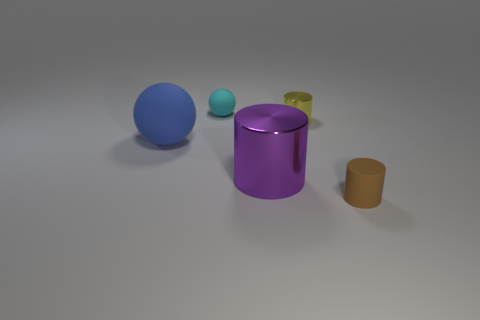Add 3 large metallic things. How many objects exist? 8 Subtract all cylinders. How many objects are left? 2 Add 2 tiny blue metallic cylinders. How many tiny blue metallic cylinders exist? 2 Subtract 0 green cylinders. How many objects are left? 5 Subtract all small yellow shiny cylinders. Subtract all big yellow metallic cylinders. How many objects are left? 4 Add 5 brown matte things. How many brown matte things are left? 6 